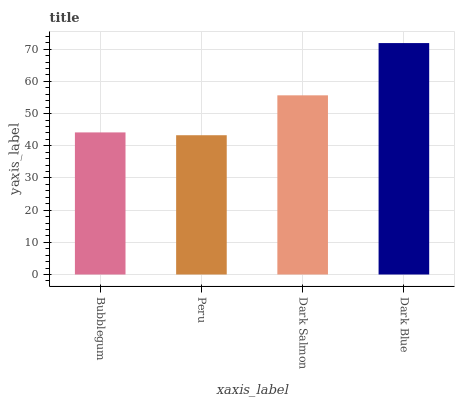Is Peru the minimum?
Answer yes or no. Yes. Is Dark Blue the maximum?
Answer yes or no. Yes. Is Dark Salmon the minimum?
Answer yes or no. No. Is Dark Salmon the maximum?
Answer yes or no. No. Is Dark Salmon greater than Peru?
Answer yes or no. Yes. Is Peru less than Dark Salmon?
Answer yes or no. Yes. Is Peru greater than Dark Salmon?
Answer yes or no. No. Is Dark Salmon less than Peru?
Answer yes or no. No. Is Dark Salmon the high median?
Answer yes or no. Yes. Is Bubblegum the low median?
Answer yes or no. Yes. Is Dark Blue the high median?
Answer yes or no. No. Is Dark Blue the low median?
Answer yes or no. No. 